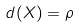Convert formula to latex. <formula><loc_0><loc_0><loc_500><loc_500>d ( X ) = \rho</formula> 